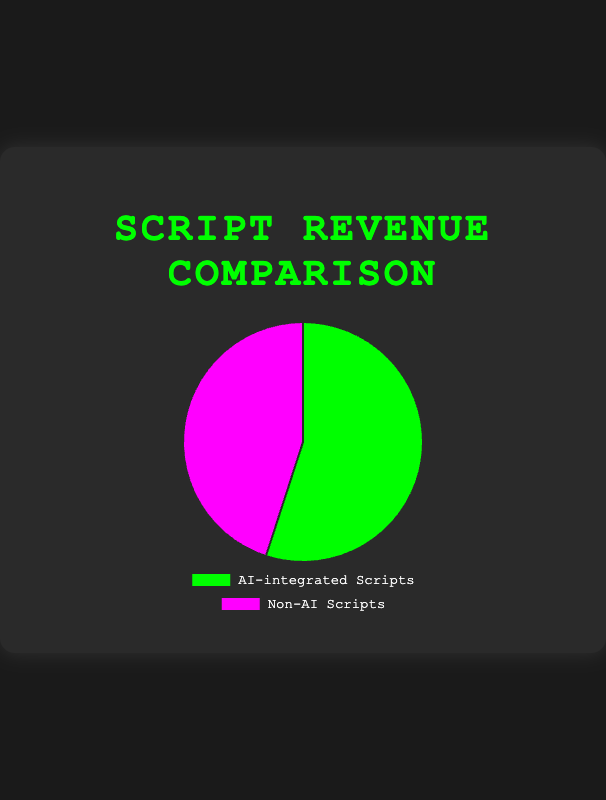Which category generated more revenue? The chart shows two categories: AI-integrated Scripts and Non-AI Scripts. By observing the data, it's evident that AI-integrated Scripts generated more revenue since its segment of the pie is larger.
Answer: AI-integrated Scripts What is the revenue difference between AI-integrated Scripts and Non-AI Scripts? To find the difference, subtract the revenue of Non-AI Scripts from the revenue of AI-integrated Scripts: 550,000,000 - 450,000,000 = 100,000,000.
Answer: 100,000,000 What percentage of the total revenue is generated by AI-integrated Scripts? First, sum the revenues of both categories: 550,000,000 + 450,000,000 = 1,000,000,000. Then, divide the revenue of AI-integrated Scripts by the total revenue and multiply by 100: (550,000,000 / 1,000,000,000) * 100 = 55%.
Answer: 55% If you were to split the revenue equally between AI-integrated and Non-AI Scripts, how much more would Non-AI Scripts need? First, divide the total revenue by 2: 1,000,000,000 / 2 = 500,000,000. Non-AI Scripts currently generate 450,000,000, so the additional amount needed is 500,000,000 - 450,000,000 = 50,000,000.
Answer: 50,000,000 Which category's segment is represented in green on the pie chart? By examining the color representation in the chart, the green segment corresponds to AI-integrated Scripts.
Answer: AI-integrated Scripts What is the total revenue generated by both categories combined? Add the revenue of AI-integrated Scripts and Non-AI Scripts: 550,000,000 + 450,000,000 = 1,000,000,000.
Answer: 1,000,000,000 If the revenue for Non-AI scripts was to increase by 20%, what would the new revenue be? Calculate the new revenue by multiplying the current revenue by 1.20 (a 20% increase): 450,000,000 * 1.20 = 540,000,000.
Answer: 540,000,000 How much revenue would AI-integrated scripts need to drop to be equal with Non-AI scripts? To find the reduction needed, subtract the revenue of Non-AI Scripts from AI-integrated Scripts: 550,000,000 - 450,000,000 = 100,000,000.
Answer: 100,000,000 